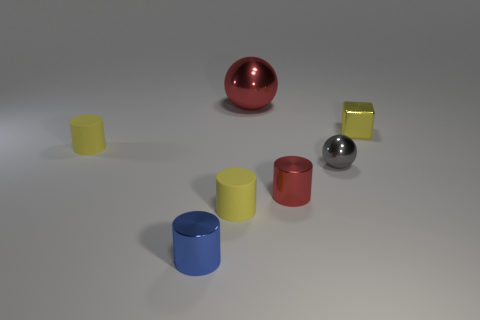What materials do the objects in the image appear to be made of? The objects in the image seem to be made of two primary materials. The spheres and the cylindrical objects have a metallic sheen, suggesting they are made of metal, while the cubes appear to have a matte surface, indicating they could be made of plastic or painted wood. 